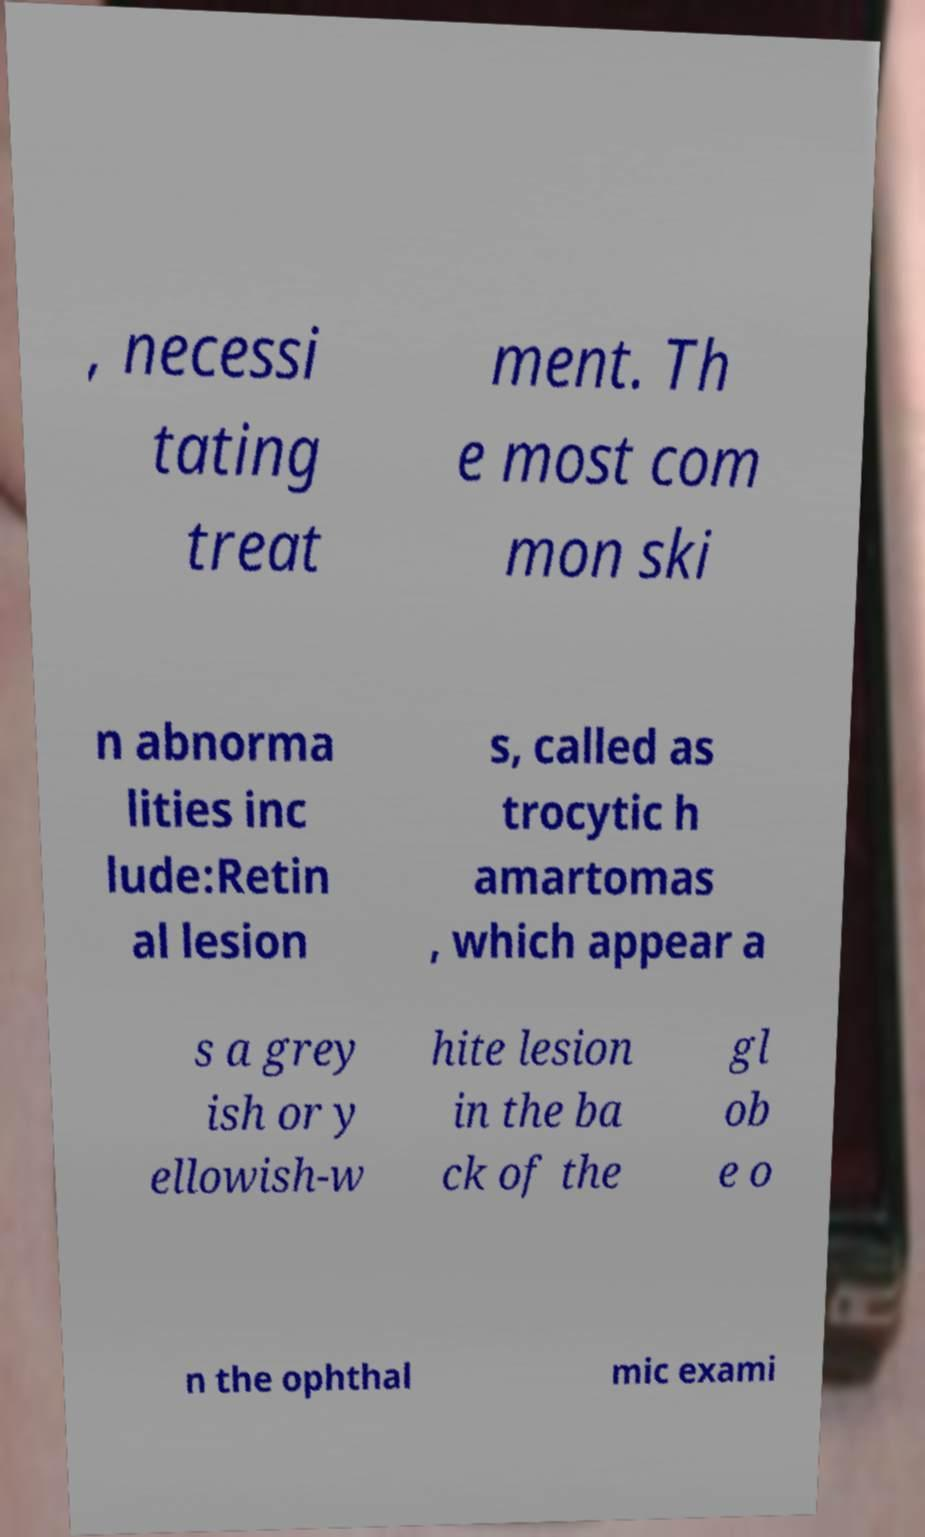Can you accurately transcribe the text from the provided image for me? , necessi tating treat ment. Th e most com mon ski n abnorma lities inc lude:Retin al lesion s, called as trocytic h amartomas , which appear a s a grey ish or y ellowish-w hite lesion in the ba ck of the gl ob e o n the ophthal mic exami 